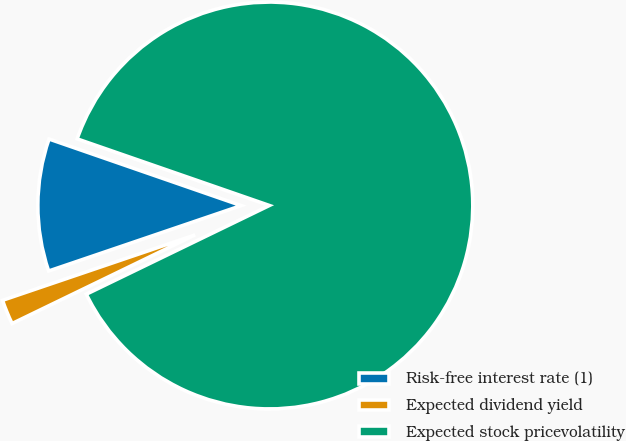Convert chart to OTSL. <chart><loc_0><loc_0><loc_500><loc_500><pie_chart><fcel>Risk-free interest rate (1)<fcel>Expected dividend yield<fcel>Expected stock pricevolatility<nl><fcel>10.52%<fcel>1.97%<fcel>87.51%<nl></chart> 